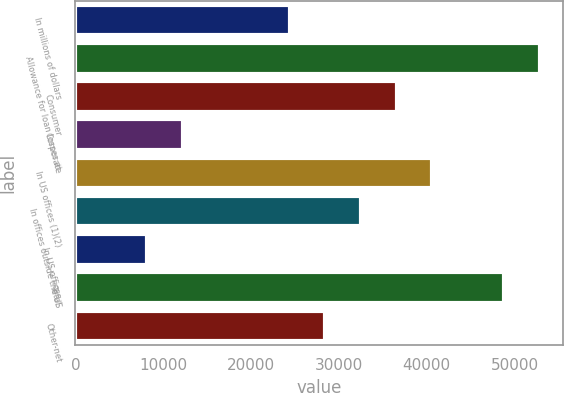Convert chart to OTSL. <chart><loc_0><loc_0><loc_500><loc_500><bar_chart><fcel>In millions of dollars<fcel>Allowance for loan losses at<fcel>Consumer<fcel>Corporate<fcel>In US offices (1)(2)<fcel>In offices outside the US<fcel>In US offices<fcel>Total<fcel>Other-net<nl><fcel>24394.7<fcel>52850.2<fcel>36589.9<fcel>12199.4<fcel>40655<fcel>32524.8<fcel>8134.32<fcel>48785.2<fcel>28459.8<nl></chart> 